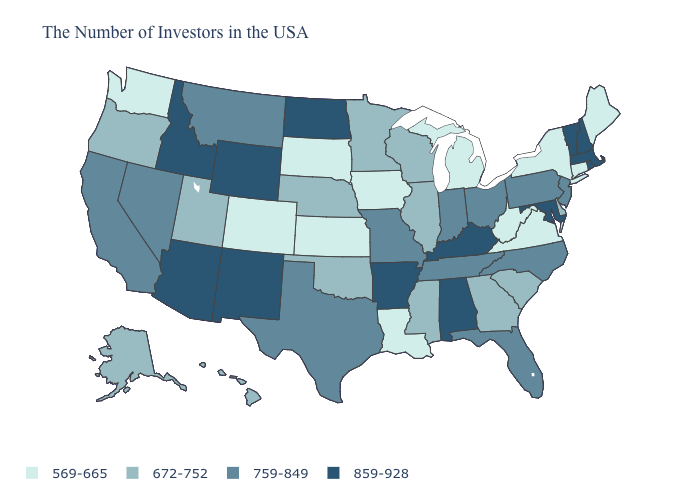Does South Dakota have the highest value in the USA?
Quick response, please. No. Among the states that border Arizona , which have the lowest value?
Answer briefly. Colorado. What is the value of South Dakota?
Answer briefly. 569-665. What is the value of Rhode Island?
Short answer required. 859-928. Does Nebraska have a lower value than Georgia?
Short answer required. No. Among the states that border Illinois , which have the highest value?
Answer briefly. Kentucky. Which states have the highest value in the USA?
Give a very brief answer. Massachusetts, Rhode Island, New Hampshire, Vermont, Maryland, Kentucky, Alabama, Arkansas, North Dakota, Wyoming, New Mexico, Arizona, Idaho. What is the value of Alabama?
Short answer required. 859-928. What is the value of Alaska?
Write a very short answer. 672-752. Which states have the lowest value in the MidWest?
Answer briefly. Michigan, Iowa, Kansas, South Dakota. What is the value of Pennsylvania?
Answer briefly. 759-849. Name the states that have a value in the range 672-752?
Be succinct. Delaware, South Carolina, Georgia, Wisconsin, Illinois, Mississippi, Minnesota, Nebraska, Oklahoma, Utah, Oregon, Alaska, Hawaii. Which states have the highest value in the USA?
Quick response, please. Massachusetts, Rhode Island, New Hampshire, Vermont, Maryland, Kentucky, Alabama, Arkansas, North Dakota, Wyoming, New Mexico, Arizona, Idaho. Name the states that have a value in the range 859-928?
Give a very brief answer. Massachusetts, Rhode Island, New Hampshire, Vermont, Maryland, Kentucky, Alabama, Arkansas, North Dakota, Wyoming, New Mexico, Arizona, Idaho. 